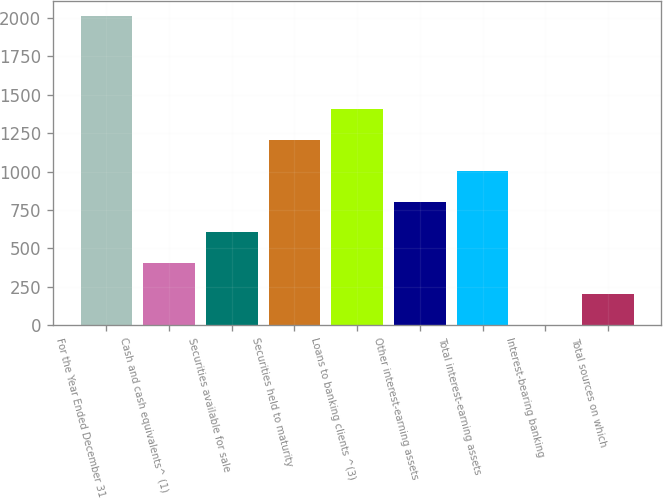Convert chart. <chart><loc_0><loc_0><loc_500><loc_500><bar_chart><fcel>For the Year Ended December 31<fcel>Cash and cash equivalents^ (1)<fcel>Securities available for sale<fcel>Securities held to maturity<fcel>Loans to banking clients ^(3)<fcel>Other interest-earning assets<fcel>Total interest-earning assets<fcel>Interest-bearing banking<fcel>Total sources on which<nl><fcel>2011<fcel>402.3<fcel>603.39<fcel>1206.66<fcel>1407.75<fcel>804.48<fcel>1005.57<fcel>0.12<fcel>201.21<nl></chart> 